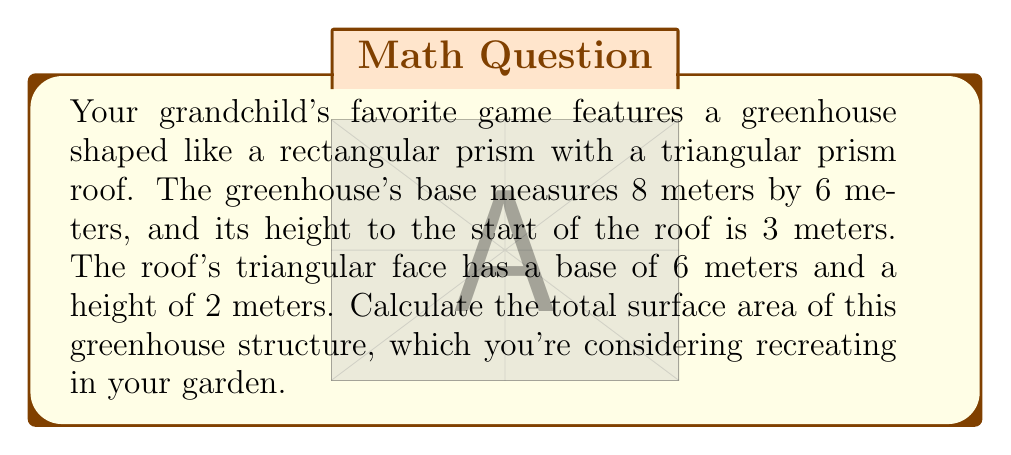Provide a solution to this math problem. Let's break this down step-by-step:

1. Calculate the area of the rectangular base:
   $$A_{base} = 8 \text{ m} \times 6 \text{ m} = 48 \text{ m}^2$$

2. Calculate the area of the two long rectangular sides:
   $$A_{long} = 2 \times (8 \text{ m} \times 3 \text{ m}) = 48 \text{ m}^2$$

3. Calculate the area of the two short rectangular sides:
   $$A_{short} = 2 \times (6 \text{ m} \times 3 \text{ m}) = 36 \text{ m}^2$$

4. Calculate the area of the two triangular ends of the roof:
   Area of one triangle: $$A_{triangle} = \frac{1}{2} \times 6 \text{ m} \times 2 \text{ m} = 6 \text{ m}^2$$
   Area of both triangles: $$A_{triangles} = 2 \times 6 \text{ m}^2 = 12 \text{ m}^2$$

5. Calculate the area of the roof rectangles:
   To find the length of the roof's slant, use the Pythagorean theorem:
   $$c^2 = 3^2 + 2^2$$
   $$c = \sqrt{13} \text{ m}$$
   Area of roof rectangles: $$A_{roof} = 2 \times (8 \text{ m} \times \sqrt{13} \text{ m}) = 16\sqrt{13} \text{ m}^2$$

6. Sum all the areas:
   $$A_{total} = A_{base} + A_{long} + A_{short} + A_{triangles} + A_{roof}$$
   $$A_{total} = 48 + 48 + 36 + 12 + 16\sqrt{13} \text{ m}^2$$
   $$A_{total} = 144 + 16\sqrt{13} \text{ m}^2$$
Answer: $144 + 16\sqrt{13} \text{ m}^2$ 